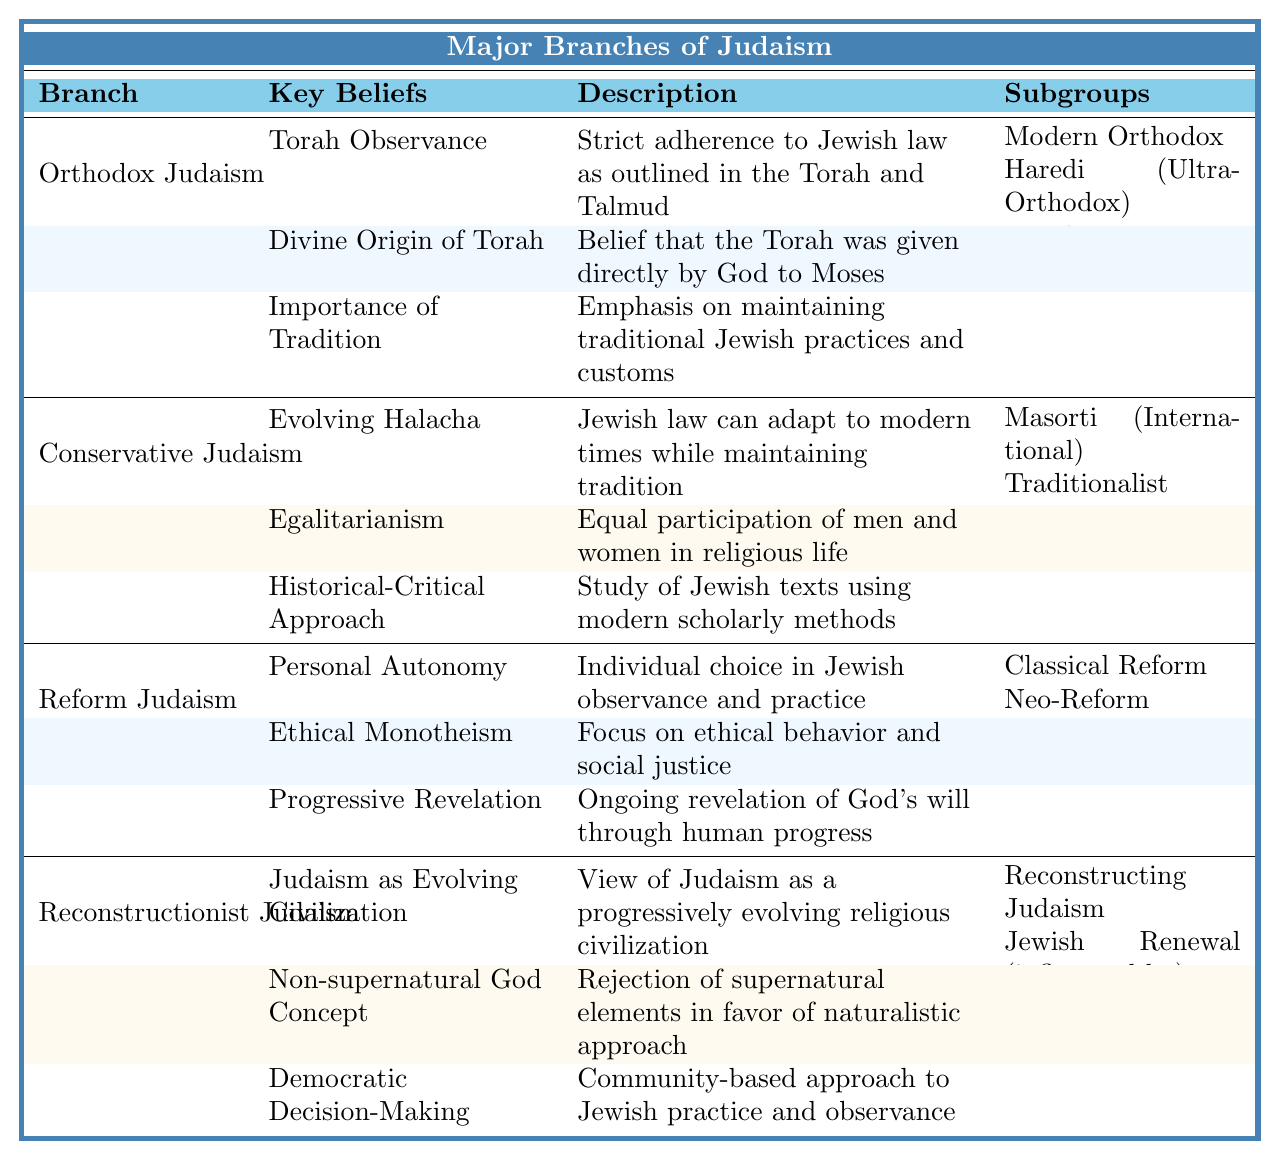What are the key beliefs of Orthodox Judaism? The table lists three key beliefs for Orthodox Judaism: Torah Observance, Divine Origin of Torah, and Importance of Tradition.
Answer: Torah Observance, Divine Origin of Torah, Importance of Tradition Which branch of Judaism emphasizes egalitarianism? The table shows that egalitarianism is a key belief of Conservative Judaism.
Answer: Conservative Judaism How many subgroups are listed under Reform Judaism? There are three subgroups mentioned: Classical Reform, Neo-Reform, and Progressive (UK). Counting them gives a total of three.
Answer: 3 Is the belief in a non-supernatural God a characteristic of Reconstructionist Judaism? Yes, the table states that the non-supernatural God concept is one of the key beliefs of Reconstructionist Judaism.
Answer: Yes Which branch has the belief in ethical monotheism? According to the table, ethical monotheism is a key belief of Reform Judaism.
Answer: Reform Judaism List one key belief of Conservative Judaism. The table indicates Evolving Halacha as one key belief of Conservative Judaism.
Answer: Evolving Halacha What is the relationship between the branch of Judaism and its subgroups? Each branch of Judaism in the table has associated subgroups listed alongside their key beliefs, indicating different interpretations or movements within that branch.
Answer: Subgroups indicate movements within each branch How many key beliefs are associated with Reconstructionist Judaism? The table indicates three key beliefs for Reconstructionist Judaism: Judaism as Evolving Civilization, Non-supernatural God Concept, and Democratic Decision-Making. Counting these gives three key beliefs.
Answer: 3 Are all branches of Judaism listed in the table? No, the table lists only four branches: Orthodox, Conservative, Reform, and Reconstructionist Judaism, which may not encompass all existing branches.
Answer: No What belief is emphasized in both Conservative Judaism and Reconstructionist Judaism? Both branches emphasize a community-based approach: Conservative Judaism through Evolving Halacha and Reconstructionist Judaism through Democratic Decision-Making.
Answer: Community-based approach Which branch shows a progressive understanding of Jewish texts? The Historical-Critical Approach, indicating a progressive understanding of Jewish texts, is a key belief in Conservative Judaism.
Answer: Conservative Judaism 